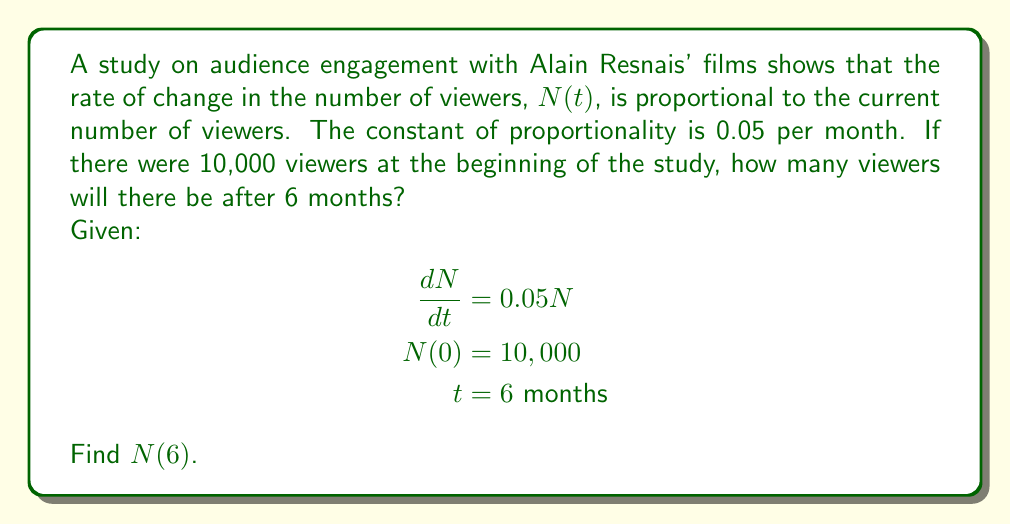Teach me how to tackle this problem. To solve this problem, we need to use the first-order linear differential equation:

$$\frac{dN}{dt} = 0.05N$$

This is a separable equation, so we can solve it as follows:

1) Separate the variables:
   $$\frac{dN}{N} = 0.05dt$$

2) Integrate both sides:
   $$\int \frac{dN}{N} = \int 0.05dt$$
   $$\ln|N| = 0.05t + C$$

3) Exponentiate both sides:
   $$N = e^{0.05t + C} = e^C \cdot e^{0.05t}$$

4) Let $A = e^C$, so our general solution is:
   $$N(t) = Ae^{0.05t}$$

5) Use the initial condition $N(0) = 10,000$ to find $A$:
   $$10,000 = Ae^{0.05 \cdot 0}$$
   $$10,000 = A$$

6) Our particular solution is:
   $$N(t) = 10,000e^{0.05t}$$

7) To find $N(6)$, we substitute $t = 6$:
   $$N(6) = 10,000e^{0.05 \cdot 6} = 10,000e^{0.3}$$

8) Calculate the final result:
   $$N(6) = 10,000 \cdot 1.3498588 \approx 13,499$$
Answer: After 6 months, there will be approximately 13,499 viewers. 